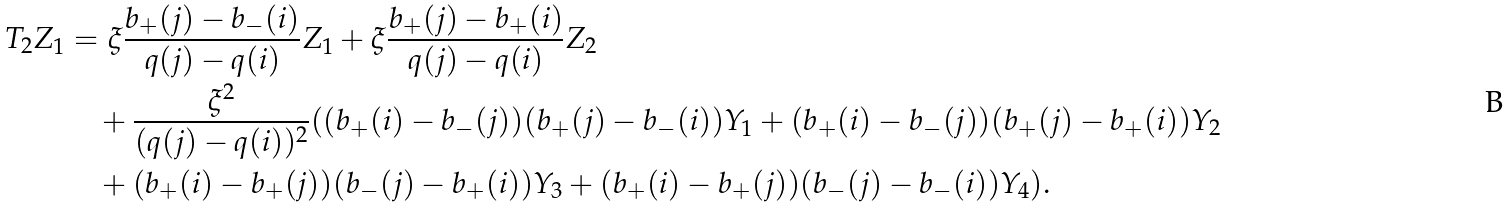Convert formula to latex. <formula><loc_0><loc_0><loc_500><loc_500>T _ { 2 } Z _ { 1 } & = \xi \frac { b _ { + } ( j ) - b _ { - } ( i ) } { q ( j ) - q ( i ) } Z _ { 1 } + \xi \frac { b _ { + } ( j ) - b _ { + } ( i ) } { q ( j ) - q ( i ) } Z _ { 2 } \\ & { \quad } + \frac { \xi ^ { 2 } } { ( q ( j ) - q ( i ) ) ^ { 2 } } ( ( b _ { + } ( i ) - b _ { - } ( j ) ) ( b _ { + } ( j ) - b _ { - } ( i ) ) Y _ { 1 } + ( b _ { + } ( i ) - b _ { - } ( j ) ) ( b _ { + } ( j ) - b _ { + } ( i ) ) Y _ { 2 } \\ & { \quad } + ( b _ { + } ( i ) - b _ { + } ( j ) ) ( b _ { - } ( j ) - b _ { + } ( i ) ) Y _ { 3 } + ( b _ { + } ( i ) - b _ { + } ( j ) ) ( b _ { - } ( j ) - b _ { - } ( i ) ) Y _ { 4 } ) .</formula> 